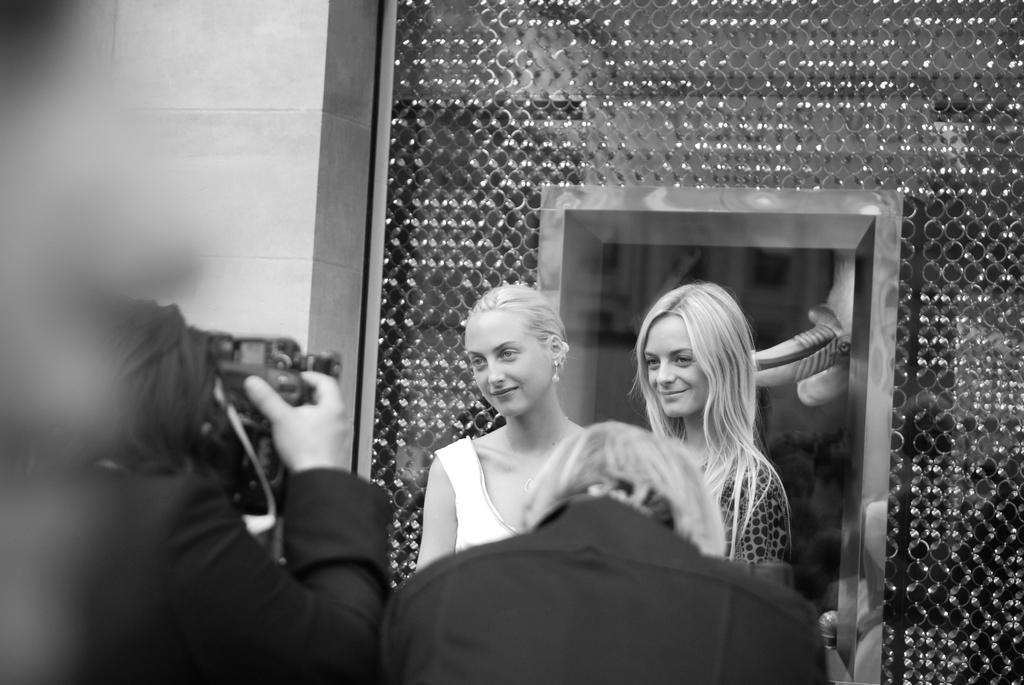What is the color scheme of the image? The image is black and white. What can be seen in the image? There are people in the image. What are some of the people doing in the image? Some people are holding objects. What is visible in the background of the image? A: There is a wall visible in the image. What is on the wall in the image? There are objects on the wall. What type of swing can be seen in the image? A: There is no swing present in the image. What is the mass of the objects being held by the people in the image? The mass of the objects being held by the people cannot be determined from the image alone. 